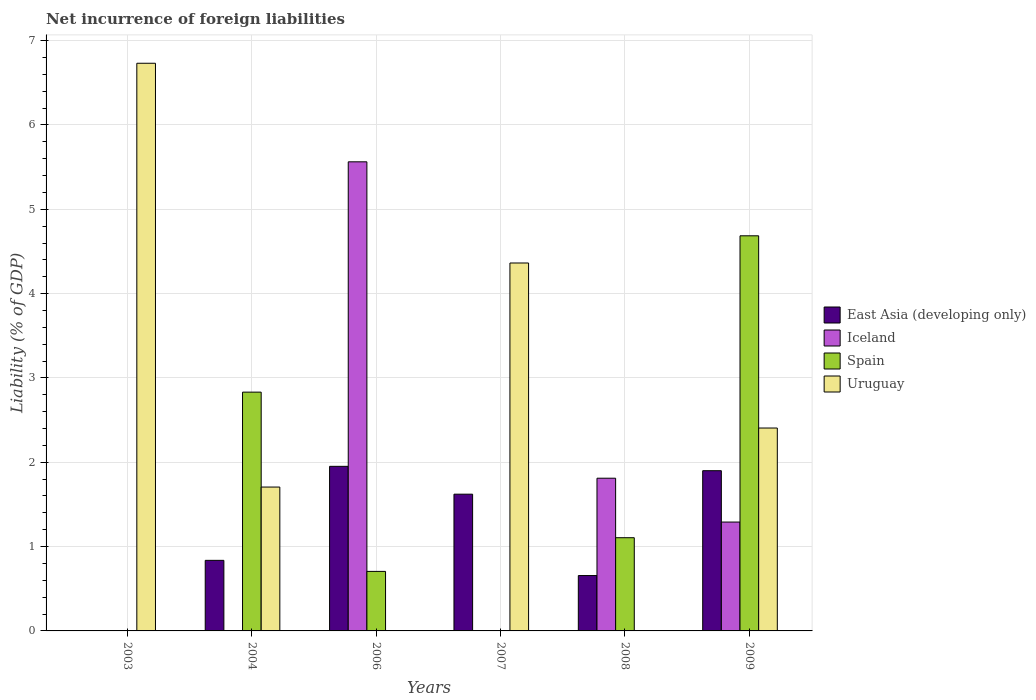How many different coloured bars are there?
Offer a terse response. 4. Are the number of bars on each tick of the X-axis equal?
Provide a short and direct response. No. How many bars are there on the 3rd tick from the right?
Offer a very short reply. 2. In how many cases, is the number of bars for a given year not equal to the number of legend labels?
Make the answer very short. 5. What is the net incurrence of foreign liabilities in Iceland in 2006?
Provide a succinct answer. 5.56. Across all years, what is the maximum net incurrence of foreign liabilities in Iceland?
Keep it short and to the point. 5.56. Across all years, what is the minimum net incurrence of foreign liabilities in Spain?
Ensure brevity in your answer.  0. In which year was the net incurrence of foreign liabilities in Uruguay maximum?
Keep it short and to the point. 2003. What is the total net incurrence of foreign liabilities in Uruguay in the graph?
Provide a short and direct response. 15.21. What is the difference between the net incurrence of foreign liabilities in Spain in 2006 and that in 2008?
Give a very brief answer. -0.4. What is the difference between the net incurrence of foreign liabilities in Uruguay in 2008 and the net incurrence of foreign liabilities in East Asia (developing only) in 2004?
Keep it short and to the point. -0.84. What is the average net incurrence of foreign liabilities in East Asia (developing only) per year?
Keep it short and to the point. 1.16. In the year 2008, what is the difference between the net incurrence of foreign liabilities in Iceland and net incurrence of foreign liabilities in East Asia (developing only)?
Offer a terse response. 1.15. In how many years, is the net incurrence of foreign liabilities in Iceland greater than 6.2 %?
Offer a terse response. 0. What is the ratio of the net incurrence of foreign liabilities in Uruguay in 2004 to that in 2009?
Your answer should be very brief. 0.71. What is the difference between the highest and the second highest net incurrence of foreign liabilities in East Asia (developing only)?
Offer a very short reply. 0.05. What is the difference between the highest and the lowest net incurrence of foreign liabilities in East Asia (developing only)?
Your response must be concise. 1.95. In how many years, is the net incurrence of foreign liabilities in Iceland greater than the average net incurrence of foreign liabilities in Iceland taken over all years?
Your answer should be very brief. 2. Is it the case that in every year, the sum of the net incurrence of foreign liabilities in East Asia (developing only) and net incurrence of foreign liabilities in Spain is greater than the sum of net incurrence of foreign liabilities in Uruguay and net incurrence of foreign liabilities in Iceland?
Provide a short and direct response. No. Is it the case that in every year, the sum of the net incurrence of foreign liabilities in Uruguay and net incurrence of foreign liabilities in Spain is greater than the net incurrence of foreign liabilities in East Asia (developing only)?
Your answer should be very brief. No. How many bars are there?
Your answer should be very brief. 16. Are all the bars in the graph horizontal?
Give a very brief answer. No. Are the values on the major ticks of Y-axis written in scientific E-notation?
Ensure brevity in your answer.  No. Where does the legend appear in the graph?
Provide a short and direct response. Center right. How are the legend labels stacked?
Provide a succinct answer. Vertical. What is the title of the graph?
Offer a terse response. Net incurrence of foreign liabilities. Does "St. Lucia" appear as one of the legend labels in the graph?
Ensure brevity in your answer.  No. What is the label or title of the Y-axis?
Ensure brevity in your answer.  Liability (% of GDP). What is the Liability (% of GDP) of Spain in 2003?
Your response must be concise. 0. What is the Liability (% of GDP) in Uruguay in 2003?
Your response must be concise. 6.73. What is the Liability (% of GDP) of East Asia (developing only) in 2004?
Provide a succinct answer. 0.84. What is the Liability (% of GDP) of Spain in 2004?
Provide a short and direct response. 2.83. What is the Liability (% of GDP) in Uruguay in 2004?
Keep it short and to the point. 1.71. What is the Liability (% of GDP) in East Asia (developing only) in 2006?
Keep it short and to the point. 1.95. What is the Liability (% of GDP) in Iceland in 2006?
Offer a terse response. 5.56. What is the Liability (% of GDP) in Spain in 2006?
Ensure brevity in your answer.  0.71. What is the Liability (% of GDP) of Uruguay in 2006?
Offer a very short reply. 0. What is the Liability (% of GDP) of East Asia (developing only) in 2007?
Offer a very short reply. 1.62. What is the Liability (% of GDP) of Iceland in 2007?
Your answer should be compact. 0. What is the Liability (% of GDP) of Uruguay in 2007?
Keep it short and to the point. 4.36. What is the Liability (% of GDP) in East Asia (developing only) in 2008?
Your answer should be compact. 0.66. What is the Liability (% of GDP) in Iceland in 2008?
Offer a terse response. 1.81. What is the Liability (% of GDP) in Spain in 2008?
Make the answer very short. 1.11. What is the Liability (% of GDP) in Uruguay in 2008?
Make the answer very short. 0. What is the Liability (% of GDP) in East Asia (developing only) in 2009?
Your response must be concise. 1.9. What is the Liability (% of GDP) of Iceland in 2009?
Your answer should be very brief. 1.29. What is the Liability (% of GDP) in Spain in 2009?
Offer a terse response. 4.69. What is the Liability (% of GDP) in Uruguay in 2009?
Keep it short and to the point. 2.41. Across all years, what is the maximum Liability (% of GDP) in East Asia (developing only)?
Your answer should be compact. 1.95. Across all years, what is the maximum Liability (% of GDP) of Iceland?
Give a very brief answer. 5.56. Across all years, what is the maximum Liability (% of GDP) of Spain?
Keep it short and to the point. 4.69. Across all years, what is the maximum Liability (% of GDP) in Uruguay?
Your answer should be compact. 6.73. Across all years, what is the minimum Liability (% of GDP) of East Asia (developing only)?
Provide a short and direct response. 0. Across all years, what is the minimum Liability (% of GDP) in Iceland?
Provide a short and direct response. 0. What is the total Liability (% of GDP) of East Asia (developing only) in the graph?
Your response must be concise. 6.97. What is the total Liability (% of GDP) in Iceland in the graph?
Provide a short and direct response. 8.66. What is the total Liability (% of GDP) of Spain in the graph?
Offer a very short reply. 9.33. What is the total Liability (% of GDP) of Uruguay in the graph?
Provide a short and direct response. 15.21. What is the difference between the Liability (% of GDP) in Uruguay in 2003 and that in 2004?
Your response must be concise. 5.03. What is the difference between the Liability (% of GDP) of Uruguay in 2003 and that in 2007?
Give a very brief answer. 2.37. What is the difference between the Liability (% of GDP) in Uruguay in 2003 and that in 2009?
Offer a terse response. 4.33. What is the difference between the Liability (% of GDP) in East Asia (developing only) in 2004 and that in 2006?
Offer a terse response. -1.11. What is the difference between the Liability (% of GDP) in Spain in 2004 and that in 2006?
Provide a short and direct response. 2.13. What is the difference between the Liability (% of GDP) in East Asia (developing only) in 2004 and that in 2007?
Ensure brevity in your answer.  -0.78. What is the difference between the Liability (% of GDP) of Uruguay in 2004 and that in 2007?
Your answer should be compact. -2.66. What is the difference between the Liability (% of GDP) in East Asia (developing only) in 2004 and that in 2008?
Give a very brief answer. 0.18. What is the difference between the Liability (% of GDP) in Spain in 2004 and that in 2008?
Provide a short and direct response. 1.73. What is the difference between the Liability (% of GDP) in East Asia (developing only) in 2004 and that in 2009?
Provide a succinct answer. -1.06. What is the difference between the Liability (% of GDP) of Spain in 2004 and that in 2009?
Your answer should be very brief. -1.85. What is the difference between the Liability (% of GDP) in East Asia (developing only) in 2006 and that in 2007?
Keep it short and to the point. 0.33. What is the difference between the Liability (% of GDP) of East Asia (developing only) in 2006 and that in 2008?
Offer a very short reply. 1.3. What is the difference between the Liability (% of GDP) in Iceland in 2006 and that in 2008?
Your answer should be very brief. 3.75. What is the difference between the Liability (% of GDP) in Spain in 2006 and that in 2008?
Ensure brevity in your answer.  -0.4. What is the difference between the Liability (% of GDP) in East Asia (developing only) in 2006 and that in 2009?
Ensure brevity in your answer.  0.05. What is the difference between the Liability (% of GDP) of Iceland in 2006 and that in 2009?
Offer a very short reply. 4.27. What is the difference between the Liability (% of GDP) of Spain in 2006 and that in 2009?
Make the answer very short. -3.98. What is the difference between the Liability (% of GDP) in East Asia (developing only) in 2007 and that in 2008?
Ensure brevity in your answer.  0.96. What is the difference between the Liability (% of GDP) of East Asia (developing only) in 2007 and that in 2009?
Your answer should be compact. -0.28. What is the difference between the Liability (% of GDP) in Uruguay in 2007 and that in 2009?
Provide a short and direct response. 1.96. What is the difference between the Liability (% of GDP) in East Asia (developing only) in 2008 and that in 2009?
Your answer should be compact. -1.24. What is the difference between the Liability (% of GDP) of Iceland in 2008 and that in 2009?
Provide a short and direct response. 0.52. What is the difference between the Liability (% of GDP) in Spain in 2008 and that in 2009?
Your answer should be compact. -3.58. What is the difference between the Liability (% of GDP) in East Asia (developing only) in 2004 and the Liability (% of GDP) in Iceland in 2006?
Give a very brief answer. -4.73. What is the difference between the Liability (% of GDP) of East Asia (developing only) in 2004 and the Liability (% of GDP) of Spain in 2006?
Give a very brief answer. 0.13. What is the difference between the Liability (% of GDP) of East Asia (developing only) in 2004 and the Liability (% of GDP) of Uruguay in 2007?
Make the answer very short. -3.53. What is the difference between the Liability (% of GDP) in Spain in 2004 and the Liability (% of GDP) in Uruguay in 2007?
Ensure brevity in your answer.  -1.53. What is the difference between the Liability (% of GDP) in East Asia (developing only) in 2004 and the Liability (% of GDP) in Iceland in 2008?
Keep it short and to the point. -0.97. What is the difference between the Liability (% of GDP) of East Asia (developing only) in 2004 and the Liability (% of GDP) of Spain in 2008?
Provide a short and direct response. -0.27. What is the difference between the Liability (% of GDP) in East Asia (developing only) in 2004 and the Liability (% of GDP) in Iceland in 2009?
Make the answer very short. -0.45. What is the difference between the Liability (% of GDP) in East Asia (developing only) in 2004 and the Liability (% of GDP) in Spain in 2009?
Ensure brevity in your answer.  -3.85. What is the difference between the Liability (% of GDP) in East Asia (developing only) in 2004 and the Liability (% of GDP) in Uruguay in 2009?
Offer a terse response. -1.57. What is the difference between the Liability (% of GDP) of Spain in 2004 and the Liability (% of GDP) of Uruguay in 2009?
Keep it short and to the point. 0.43. What is the difference between the Liability (% of GDP) in East Asia (developing only) in 2006 and the Liability (% of GDP) in Uruguay in 2007?
Ensure brevity in your answer.  -2.41. What is the difference between the Liability (% of GDP) in Iceland in 2006 and the Liability (% of GDP) in Uruguay in 2007?
Make the answer very short. 1.2. What is the difference between the Liability (% of GDP) of Spain in 2006 and the Liability (% of GDP) of Uruguay in 2007?
Provide a short and direct response. -3.66. What is the difference between the Liability (% of GDP) of East Asia (developing only) in 2006 and the Liability (% of GDP) of Iceland in 2008?
Keep it short and to the point. 0.14. What is the difference between the Liability (% of GDP) of East Asia (developing only) in 2006 and the Liability (% of GDP) of Spain in 2008?
Keep it short and to the point. 0.85. What is the difference between the Liability (% of GDP) of Iceland in 2006 and the Liability (% of GDP) of Spain in 2008?
Your answer should be very brief. 4.46. What is the difference between the Liability (% of GDP) of East Asia (developing only) in 2006 and the Liability (% of GDP) of Iceland in 2009?
Ensure brevity in your answer.  0.66. What is the difference between the Liability (% of GDP) in East Asia (developing only) in 2006 and the Liability (% of GDP) in Spain in 2009?
Provide a short and direct response. -2.73. What is the difference between the Liability (% of GDP) of East Asia (developing only) in 2006 and the Liability (% of GDP) of Uruguay in 2009?
Provide a succinct answer. -0.45. What is the difference between the Liability (% of GDP) in Iceland in 2006 and the Liability (% of GDP) in Spain in 2009?
Give a very brief answer. 0.88. What is the difference between the Liability (% of GDP) in Iceland in 2006 and the Liability (% of GDP) in Uruguay in 2009?
Make the answer very short. 3.16. What is the difference between the Liability (% of GDP) of Spain in 2006 and the Liability (% of GDP) of Uruguay in 2009?
Ensure brevity in your answer.  -1.7. What is the difference between the Liability (% of GDP) in East Asia (developing only) in 2007 and the Liability (% of GDP) in Iceland in 2008?
Offer a very short reply. -0.19. What is the difference between the Liability (% of GDP) of East Asia (developing only) in 2007 and the Liability (% of GDP) of Spain in 2008?
Ensure brevity in your answer.  0.52. What is the difference between the Liability (% of GDP) in East Asia (developing only) in 2007 and the Liability (% of GDP) in Iceland in 2009?
Provide a succinct answer. 0.33. What is the difference between the Liability (% of GDP) in East Asia (developing only) in 2007 and the Liability (% of GDP) in Spain in 2009?
Offer a terse response. -3.06. What is the difference between the Liability (% of GDP) of East Asia (developing only) in 2007 and the Liability (% of GDP) of Uruguay in 2009?
Offer a terse response. -0.78. What is the difference between the Liability (% of GDP) in East Asia (developing only) in 2008 and the Liability (% of GDP) in Iceland in 2009?
Provide a short and direct response. -0.63. What is the difference between the Liability (% of GDP) of East Asia (developing only) in 2008 and the Liability (% of GDP) of Spain in 2009?
Offer a terse response. -4.03. What is the difference between the Liability (% of GDP) of East Asia (developing only) in 2008 and the Liability (% of GDP) of Uruguay in 2009?
Give a very brief answer. -1.75. What is the difference between the Liability (% of GDP) in Iceland in 2008 and the Liability (% of GDP) in Spain in 2009?
Your answer should be very brief. -2.87. What is the difference between the Liability (% of GDP) of Iceland in 2008 and the Liability (% of GDP) of Uruguay in 2009?
Offer a very short reply. -0.6. What is the difference between the Liability (% of GDP) of Spain in 2008 and the Liability (% of GDP) of Uruguay in 2009?
Your response must be concise. -1.3. What is the average Liability (% of GDP) of East Asia (developing only) per year?
Provide a short and direct response. 1.16. What is the average Liability (% of GDP) of Iceland per year?
Give a very brief answer. 1.44. What is the average Liability (% of GDP) of Spain per year?
Your response must be concise. 1.55. What is the average Liability (% of GDP) of Uruguay per year?
Offer a terse response. 2.53. In the year 2004, what is the difference between the Liability (% of GDP) in East Asia (developing only) and Liability (% of GDP) in Spain?
Your answer should be compact. -1.99. In the year 2004, what is the difference between the Liability (% of GDP) of East Asia (developing only) and Liability (% of GDP) of Uruguay?
Provide a succinct answer. -0.87. In the year 2004, what is the difference between the Liability (% of GDP) in Spain and Liability (% of GDP) in Uruguay?
Give a very brief answer. 1.13. In the year 2006, what is the difference between the Liability (% of GDP) of East Asia (developing only) and Liability (% of GDP) of Iceland?
Your response must be concise. -3.61. In the year 2006, what is the difference between the Liability (% of GDP) in East Asia (developing only) and Liability (% of GDP) in Spain?
Give a very brief answer. 1.25. In the year 2006, what is the difference between the Liability (% of GDP) of Iceland and Liability (% of GDP) of Spain?
Your answer should be very brief. 4.86. In the year 2007, what is the difference between the Liability (% of GDP) in East Asia (developing only) and Liability (% of GDP) in Uruguay?
Offer a very short reply. -2.74. In the year 2008, what is the difference between the Liability (% of GDP) of East Asia (developing only) and Liability (% of GDP) of Iceland?
Your response must be concise. -1.15. In the year 2008, what is the difference between the Liability (% of GDP) of East Asia (developing only) and Liability (% of GDP) of Spain?
Offer a terse response. -0.45. In the year 2008, what is the difference between the Liability (% of GDP) in Iceland and Liability (% of GDP) in Spain?
Give a very brief answer. 0.71. In the year 2009, what is the difference between the Liability (% of GDP) of East Asia (developing only) and Liability (% of GDP) of Iceland?
Your answer should be very brief. 0.61. In the year 2009, what is the difference between the Liability (% of GDP) of East Asia (developing only) and Liability (% of GDP) of Spain?
Make the answer very short. -2.79. In the year 2009, what is the difference between the Liability (% of GDP) in East Asia (developing only) and Liability (% of GDP) in Uruguay?
Keep it short and to the point. -0.51. In the year 2009, what is the difference between the Liability (% of GDP) in Iceland and Liability (% of GDP) in Spain?
Your answer should be compact. -3.39. In the year 2009, what is the difference between the Liability (% of GDP) of Iceland and Liability (% of GDP) of Uruguay?
Keep it short and to the point. -1.12. In the year 2009, what is the difference between the Liability (% of GDP) of Spain and Liability (% of GDP) of Uruguay?
Give a very brief answer. 2.28. What is the ratio of the Liability (% of GDP) of Uruguay in 2003 to that in 2004?
Your answer should be compact. 3.95. What is the ratio of the Liability (% of GDP) in Uruguay in 2003 to that in 2007?
Your answer should be very brief. 1.54. What is the ratio of the Liability (% of GDP) of Uruguay in 2003 to that in 2009?
Ensure brevity in your answer.  2.8. What is the ratio of the Liability (% of GDP) of East Asia (developing only) in 2004 to that in 2006?
Your answer should be very brief. 0.43. What is the ratio of the Liability (% of GDP) of Spain in 2004 to that in 2006?
Your response must be concise. 4.01. What is the ratio of the Liability (% of GDP) in East Asia (developing only) in 2004 to that in 2007?
Your answer should be very brief. 0.52. What is the ratio of the Liability (% of GDP) of Uruguay in 2004 to that in 2007?
Provide a short and direct response. 0.39. What is the ratio of the Liability (% of GDP) in East Asia (developing only) in 2004 to that in 2008?
Make the answer very short. 1.27. What is the ratio of the Liability (% of GDP) of Spain in 2004 to that in 2008?
Your answer should be very brief. 2.56. What is the ratio of the Liability (% of GDP) in East Asia (developing only) in 2004 to that in 2009?
Your answer should be very brief. 0.44. What is the ratio of the Liability (% of GDP) of Spain in 2004 to that in 2009?
Provide a succinct answer. 0.6. What is the ratio of the Liability (% of GDP) in Uruguay in 2004 to that in 2009?
Your answer should be compact. 0.71. What is the ratio of the Liability (% of GDP) in East Asia (developing only) in 2006 to that in 2007?
Give a very brief answer. 1.2. What is the ratio of the Liability (% of GDP) of East Asia (developing only) in 2006 to that in 2008?
Give a very brief answer. 2.97. What is the ratio of the Liability (% of GDP) in Iceland in 2006 to that in 2008?
Offer a very short reply. 3.07. What is the ratio of the Liability (% of GDP) of Spain in 2006 to that in 2008?
Your response must be concise. 0.64. What is the ratio of the Liability (% of GDP) of East Asia (developing only) in 2006 to that in 2009?
Ensure brevity in your answer.  1.03. What is the ratio of the Liability (% of GDP) in Iceland in 2006 to that in 2009?
Ensure brevity in your answer.  4.31. What is the ratio of the Liability (% of GDP) of Spain in 2006 to that in 2009?
Your answer should be very brief. 0.15. What is the ratio of the Liability (% of GDP) of East Asia (developing only) in 2007 to that in 2008?
Your answer should be very brief. 2.47. What is the ratio of the Liability (% of GDP) of East Asia (developing only) in 2007 to that in 2009?
Provide a short and direct response. 0.85. What is the ratio of the Liability (% of GDP) of Uruguay in 2007 to that in 2009?
Offer a terse response. 1.81. What is the ratio of the Liability (% of GDP) in East Asia (developing only) in 2008 to that in 2009?
Provide a succinct answer. 0.35. What is the ratio of the Liability (% of GDP) of Iceland in 2008 to that in 2009?
Offer a terse response. 1.4. What is the ratio of the Liability (% of GDP) of Spain in 2008 to that in 2009?
Provide a short and direct response. 0.24. What is the difference between the highest and the second highest Liability (% of GDP) of East Asia (developing only)?
Make the answer very short. 0.05. What is the difference between the highest and the second highest Liability (% of GDP) in Iceland?
Keep it short and to the point. 3.75. What is the difference between the highest and the second highest Liability (% of GDP) in Spain?
Keep it short and to the point. 1.85. What is the difference between the highest and the second highest Liability (% of GDP) of Uruguay?
Give a very brief answer. 2.37. What is the difference between the highest and the lowest Liability (% of GDP) in East Asia (developing only)?
Your answer should be compact. 1.95. What is the difference between the highest and the lowest Liability (% of GDP) of Iceland?
Give a very brief answer. 5.56. What is the difference between the highest and the lowest Liability (% of GDP) of Spain?
Your response must be concise. 4.69. What is the difference between the highest and the lowest Liability (% of GDP) in Uruguay?
Your response must be concise. 6.73. 